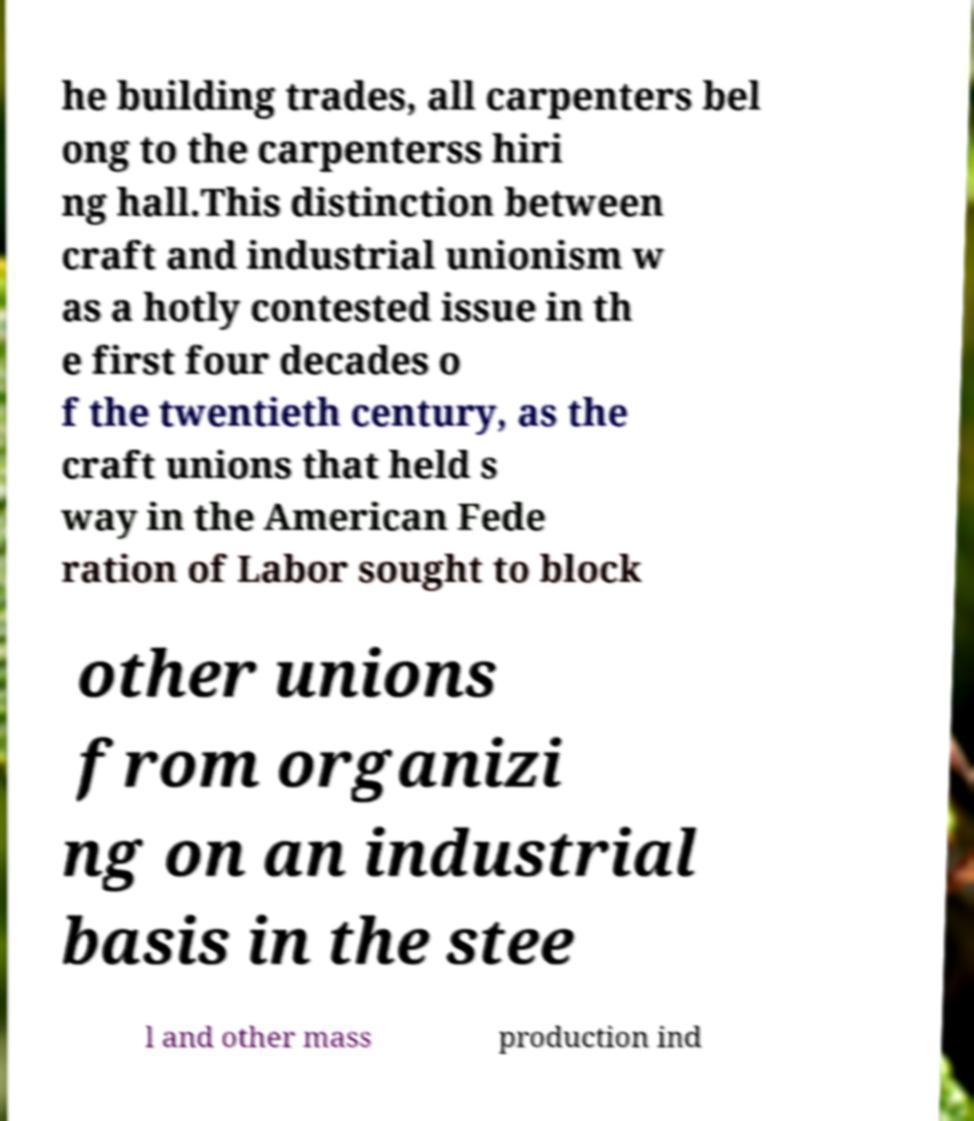Could you assist in decoding the text presented in this image and type it out clearly? he building trades, all carpenters bel ong to the carpenterss hiri ng hall.This distinction between craft and industrial unionism w as a hotly contested issue in th e first four decades o f the twentieth century, as the craft unions that held s way in the American Fede ration of Labor sought to block other unions from organizi ng on an industrial basis in the stee l and other mass production ind 